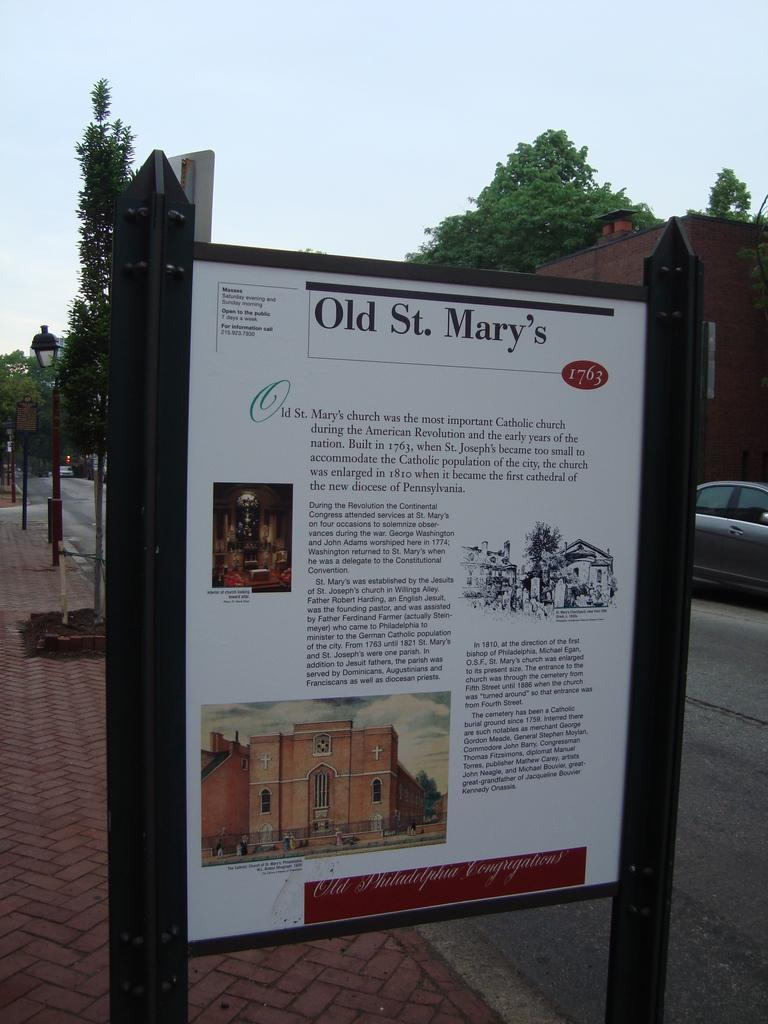What can be seen on the road in the image? There are vehicles on the road in the image. What structures are visible in the image? There are buildings visible in the image. What type of natural elements can be seen in the image? There are trees in the image. What objects are present in the image that are not vehicles or buildings? There are boards present in the image. What type of tail can be seen on the cook in the image? There is no cook or tail present in the image. What shape is the ice cream in the image? There is no ice cream present in the image. 